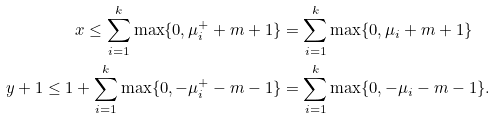<formula> <loc_0><loc_0><loc_500><loc_500>x \leq \sum _ { i = 1 } ^ { k } \max \{ 0 , \mu ^ { + } _ { i } + m + 1 \} & = \sum _ { i = 1 } ^ { k } \max \{ 0 , \mu _ { i } + m + 1 \} \\ y + 1 \leq 1 + \sum _ { i = 1 } ^ { k } \max \{ 0 , - \mu ^ { + } _ { i } - m - 1 \} & = \sum _ { i = 1 } ^ { k } \max \{ 0 , - \mu _ { i } - m - 1 \} .</formula> 